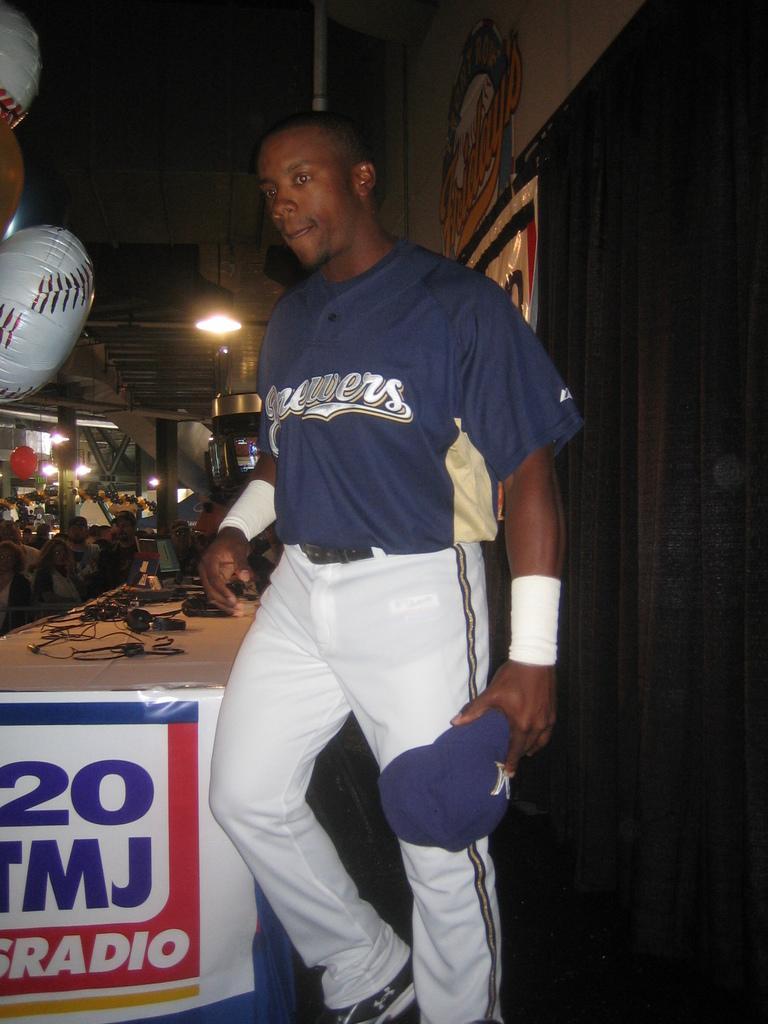Can you describe this image briefly? In this picture we can see a man is walking and holding a cap, on the left side there is a table, we can see some wires on the table, in the background there are some people sitting, we can also see some lights in the background, there is a banner in the front, we can see balloons at the left top of the picture. 